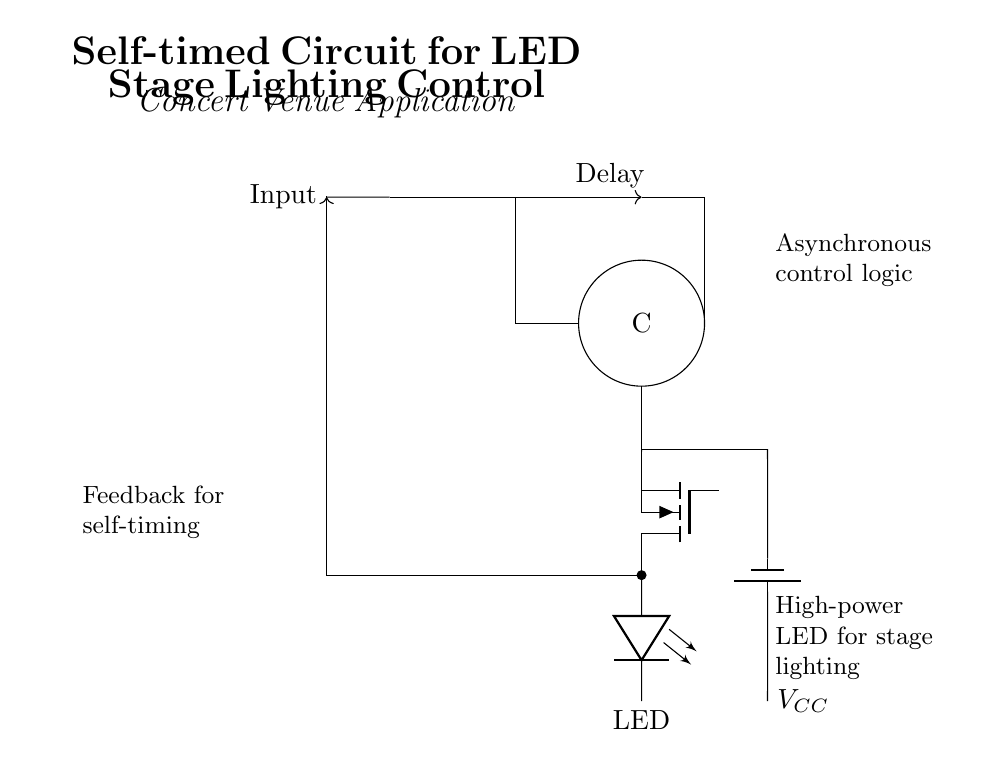What is the primary function of the C-element in this circuit? The C-element serves as a synchronization mechanism that controls the output state based on the input signals. It ensures that the output is only activated when certain conditions (logic levels of the input) are met, providing a self-timed operation.
Answer: synchronization mechanism What type of LED is used in this circuit? The circuit specifies a "Tnigfete" component as the LED driver, which indicates that a high-power LED is intended for stage lighting control. This detail emphasizes that the circuit is designed to drive LEDs that require significant current.
Answer: high-power LED What does the feedback loop provide for this circuit? The feedback loop allows the circuit to self-regulate by returning the output signal back to the input, thus ensuring that the lighting control functions in a timed sequence without needing external input signals. This is crucial for generating synchronized lighting effects.
Answer: self-regulation What is the role of the battery in this circuit? The battery provides the necessary power supply to operate the entire circuit, ensuring that all components receive the required voltage for operation. In this case, it is marked as "V_CC," which signifies a positive voltage supply.
Answer: power supply How many main components are in this circuit configuration? The circuit clearly displays several components: an input wave, a delay line, a C-element, an LED driver, and a power supply, which sums up to five primary components involved in the operation of the circuit.
Answer: five components 